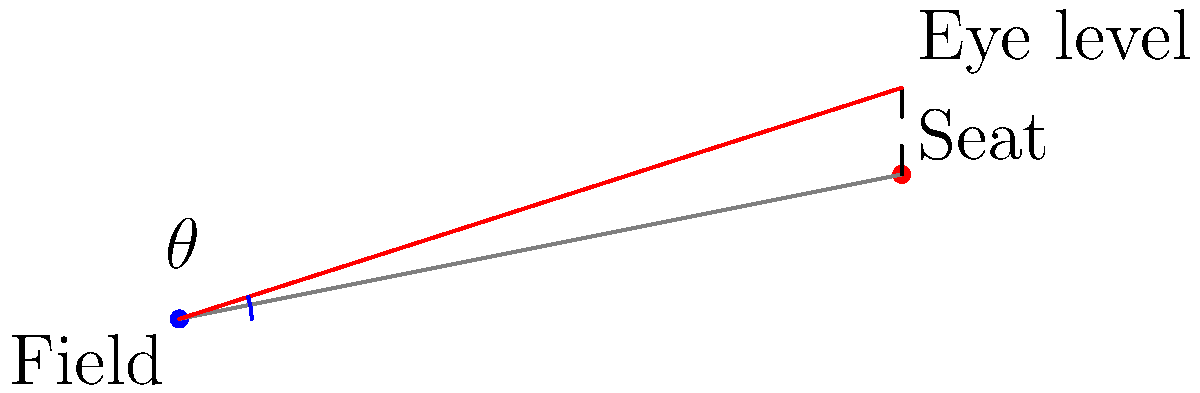In a sports stadium, a spectator's seat is 10 meters away from the field and 2 meters above ground level. If the average eye level is 1.2 meters above the seat, what is the optimal viewing angle $\theta$ (in degrees) for the spectator to view the field? To calculate the optimal viewing angle, we need to follow these steps:

1. Identify the relevant measurements:
   - Distance from field to seat: 10 meters
   - Height of seat above ground: 2 meters
   - Eye level above seat: 1.2 meters

2. Calculate the total height of the spectator's eye level above the field:
   $\text{Total height} = \text{Seat height} + \text{Eye level above seat}$
   $\text{Total height} = 2 \text{ m} + 1.2 \text{ m} = 3.2 \text{ m}$

3. Use the arctangent function to calculate the angle:
   $\theta = \arctan(\frac{\text{Total height}}{\text{Distance from field}})$
   $\theta = \arctan(\frac{3.2 \text{ m}}{10 \text{ m}})$

4. Convert the result from radians to degrees:
   $\theta = \arctan(0.32) \times \frac{180°}{\pi}$

5. Calculate the final result:
   $\theta \approx 17.74°$

Therefore, the optimal viewing angle for the spectator is approximately 17.74 degrees.
Answer: 17.74° 